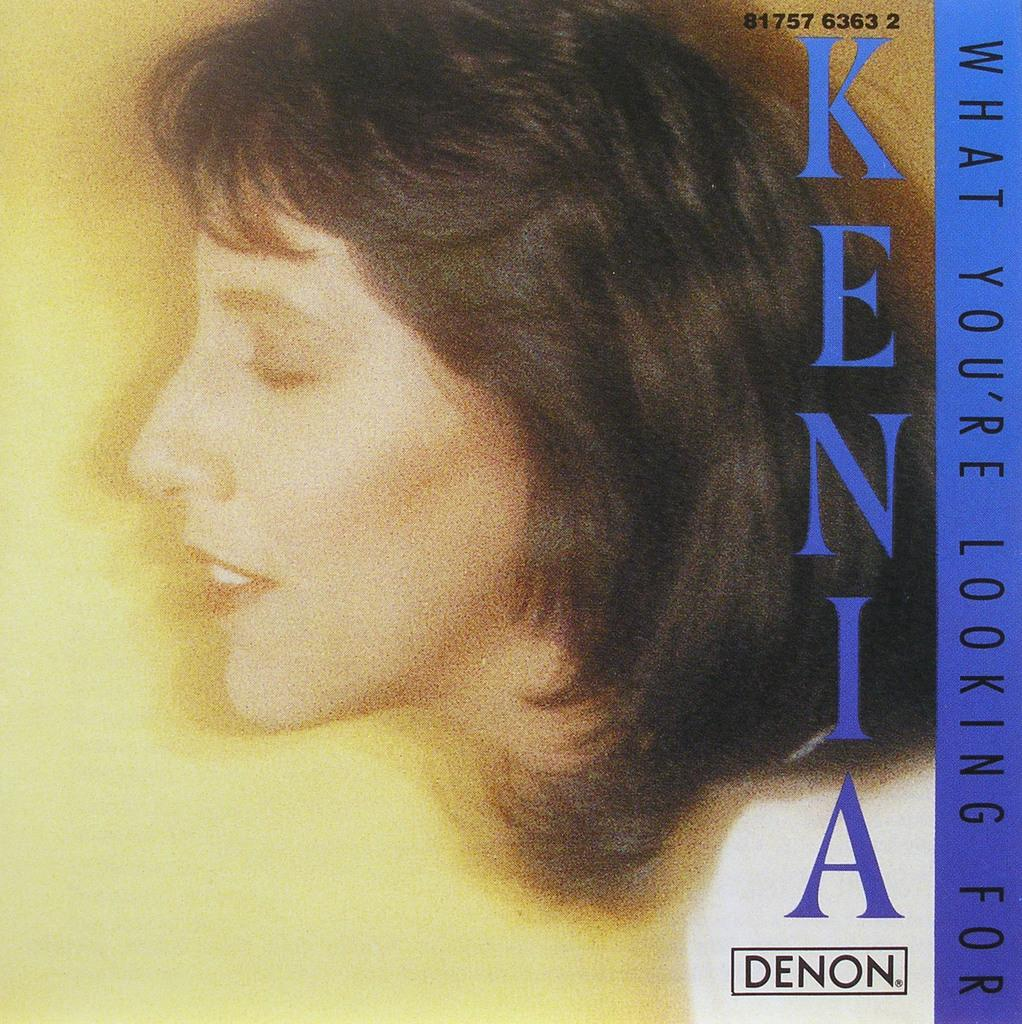Who is the main subject in the image? There is a woman in the image. How is the woman positioned in the image? The woman is shown in a side view. What can be seen on the right side of the image? There is edited text on the right side of the image. What is the color of the edited text? The edited text is in blue color. Is there a flame visible in the image? No, there is no flame present in the image. What type of soda is being served in the image? There is no soda present in the image; it features a woman in a side view with edited text on the right side. 